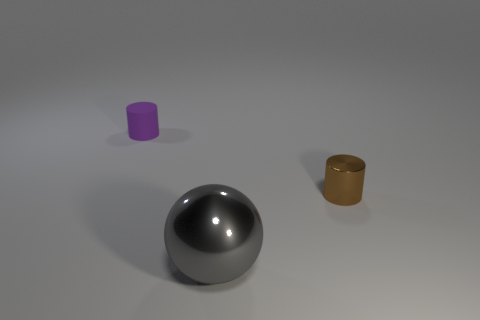What number of things are both to the left of the metal cylinder and behind the shiny sphere?
Provide a succinct answer. 1. What material is the brown cylinder?
Offer a very short reply. Metal. What number of things are either brown metallic things or gray objects?
Your answer should be compact. 2. There is a cylinder in front of the purple rubber thing; does it have the same size as the cylinder that is to the left of the big gray sphere?
Offer a terse response. Yes. How many other objects are there of the same size as the purple rubber cylinder?
Ensure brevity in your answer.  1. What number of objects are small cylinders that are in front of the purple thing or tiny shiny cylinders that are in front of the purple thing?
Provide a short and direct response. 1. Is the material of the gray thing the same as the small thing to the left of the gray sphere?
Your answer should be very brief. No. How many other things are there of the same shape as the tiny purple matte thing?
Your answer should be compact. 1. The thing in front of the small thing that is right of the gray sphere that is in front of the small matte thing is made of what material?
Your answer should be compact. Metal. Is the number of tiny brown shiny cylinders that are left of the large object the same as the number of big metallic balls?
Provide a succinct answer. No. 